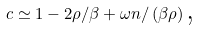Convert formula to latex. <formula><loc_0><loc_0><loc_500><loc_500>c \simeq 1 - 2 \rho / \beta + \omega n / \left ( \beta \rho \right ) \text {,}</formula> 